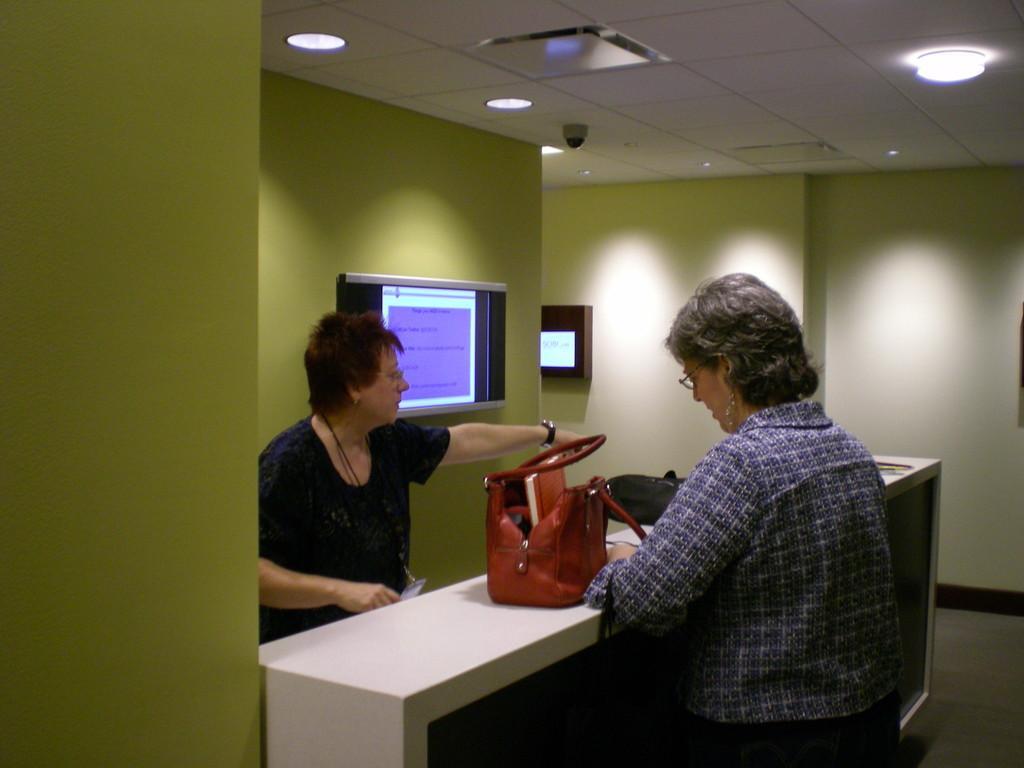Could you give a brief overview of what you see in this image? Here we can see two women sitting on chairs in front of a table and on the table we can see bags. Here we can see screens over a wall. This is ceiling, light and camera. This is a floor. 